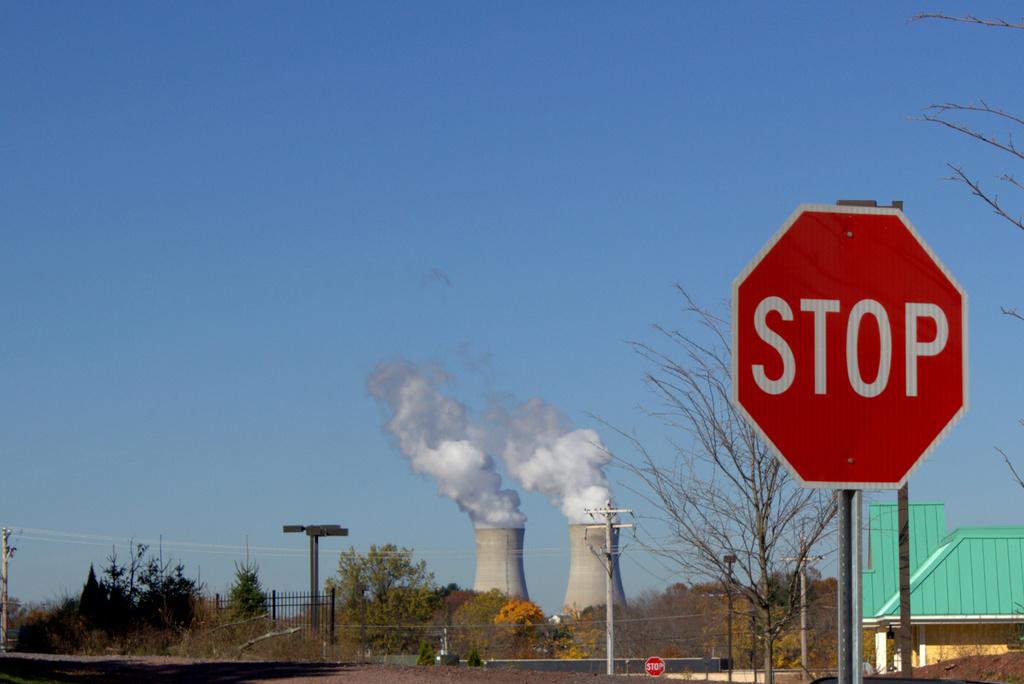What kind of sign is shown?
Ensure brevity in your answer.  Stop. 